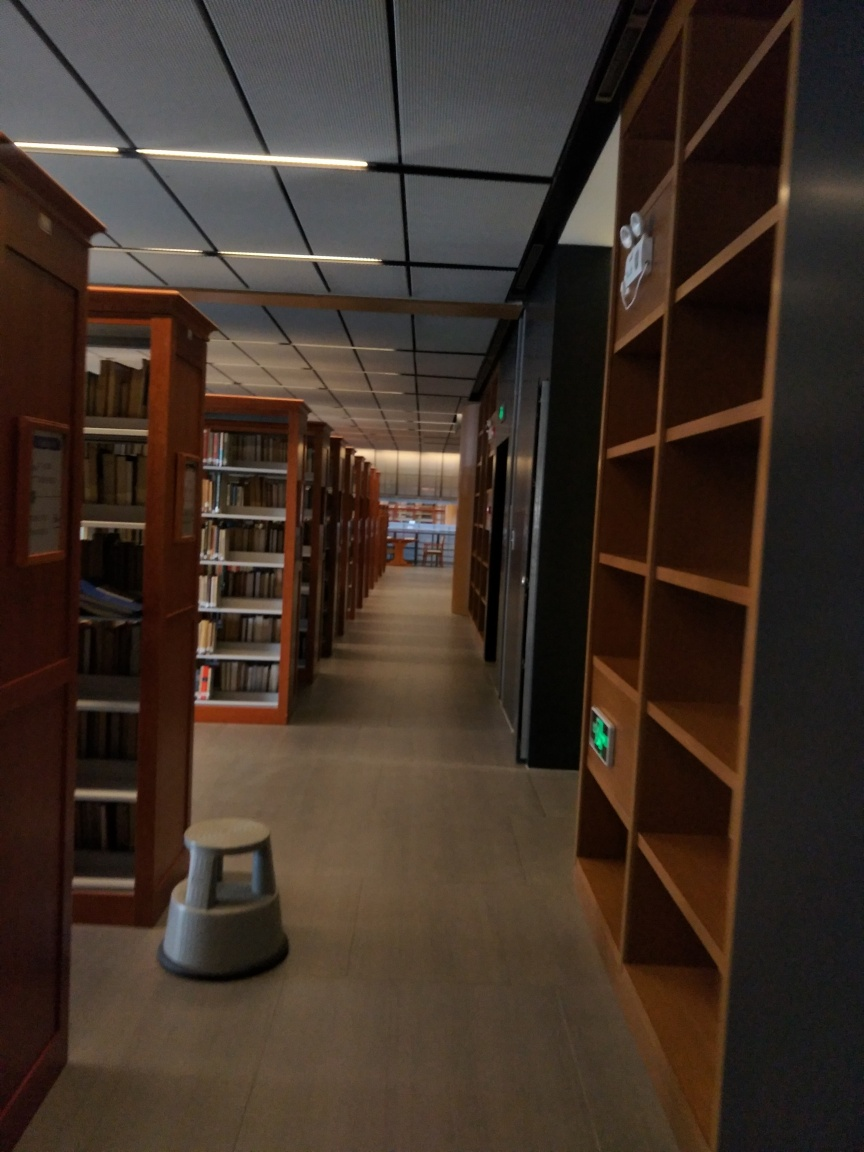What is the general mood or atmosphere conveyed by the image? The library aisle emanates a sense of tranquility and order. The absence of people and the organized shelves contribute to a contemplative and studious atmosphere. What kind of library is this? For example, public, university, or specialty? While specific details are not visible to determine the exact type of library, the structured shelving and modern lighting suggest it could be an academic or a public library designed for focused research or reading. 